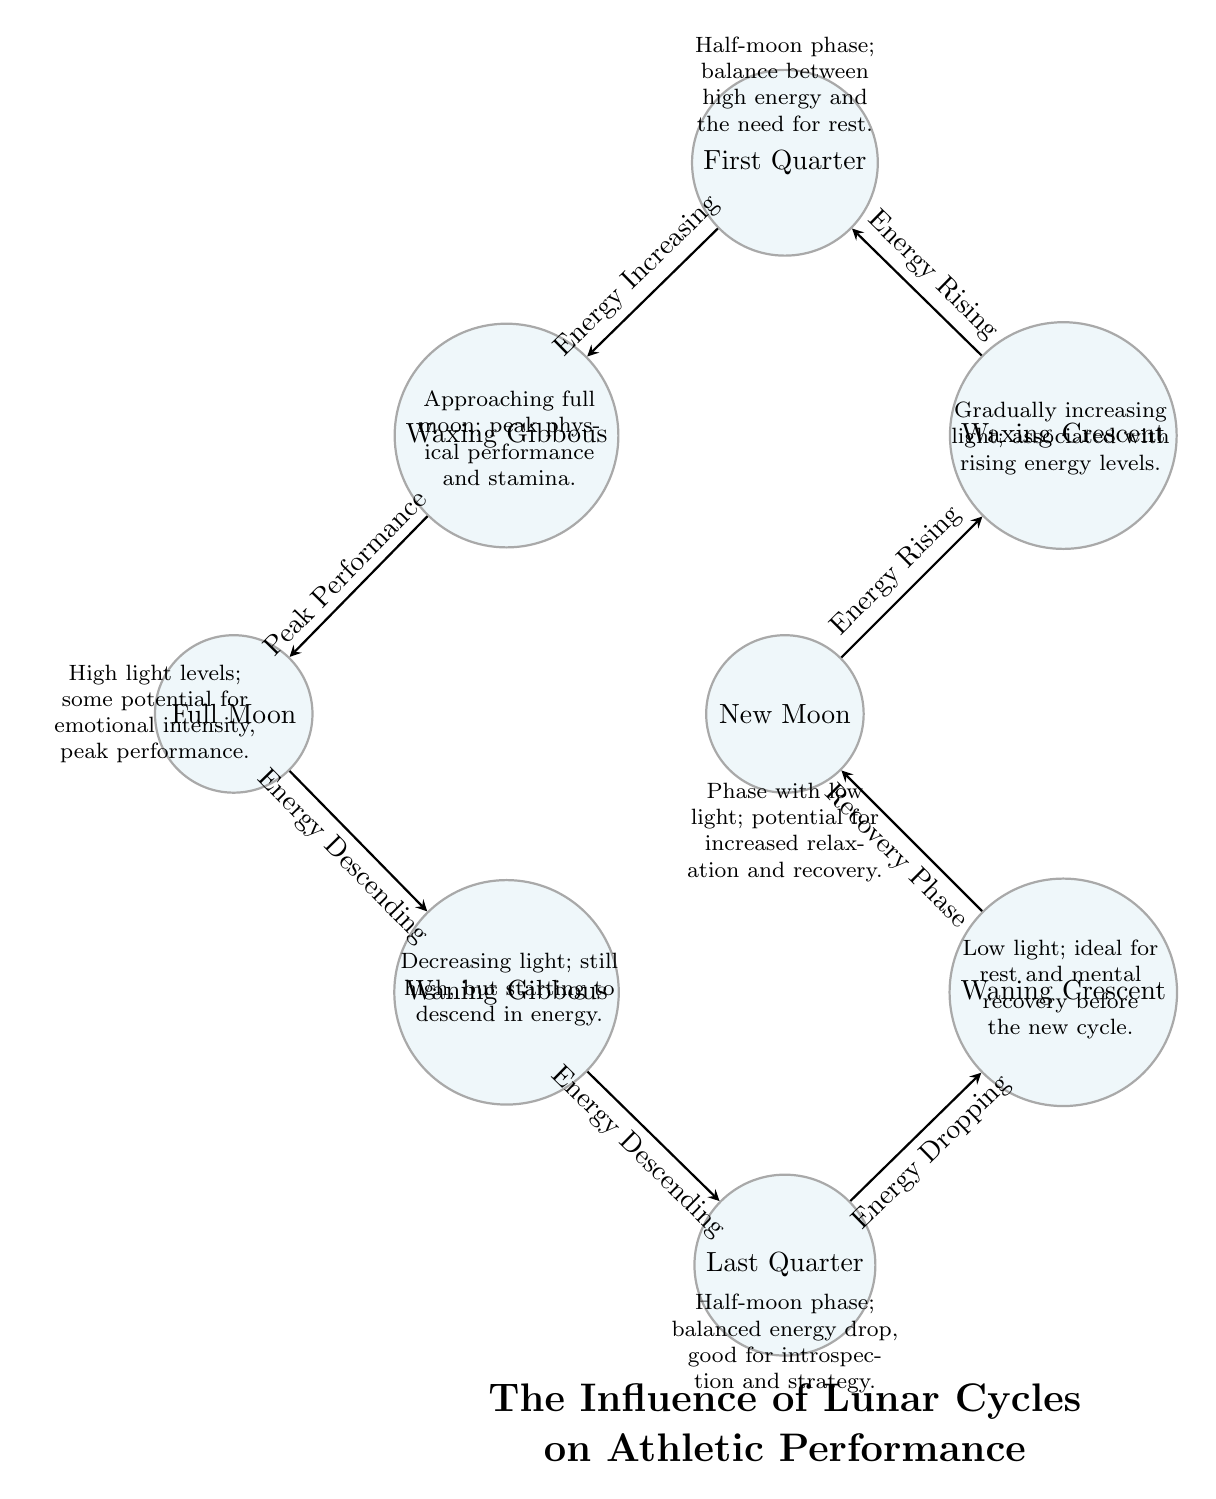What is the first moon phase mentioned in the diagram? The first node in the diagram is labeled "New Moon," indicating that this is the first phase presented.
Answer: New Moon How many moon phases are represented in the diagram? The diagram shows a total of eight nodes, each representing a different moon phase. Thus, there are eight moon phases.
Answer: 8 Which phase has energy increasing? The arrows indicate that energy is increasing from the "Waxing Crescent" to the "First Quarter" and from the "First Quarter" to the "Waxing Gibbous." The query asks for a specific phase where this occurs; "First Quarter" meets this criterion as it follows a phase with rising energy.
Answer: First Quarter What is the relationship between the Full Moon and the Waning Gibbous? The diagram states that after reaching "Full Moon," the energy is descending toward the "Waning Gibbous." This indicates that following the peak performance at the Full Moon, there is a decrease in energy.
Answer: Energy Descending Which moon phase is associated with peak performance? The diagram clearly labels the "Full Moon" as the phase where peak physical performance and stamina are observed, making it the focus for athletes aiming for high performance.
Answer: Full Moon In which phase is energy dropping described? The diagram indicates that during the "Waning Crescent," the energy is described as dropping. This information is collected from the edges indicating that energy culminates in a drop from the previous phases.
Answer: Waning Crescent What type of phase is the New Moon classified as? The New Moon is described as having low light and being a potential recovery phase, which frames its classification as a phase suited for relaxation and restoration in athletic training contexts.
Answer: Recovery Phase What follows after the Waxing Gibbous phase according to the diagram? The transition from the "Waxing Gibbous" phase leads directly to the "Full Moon" phase, marking the peak energy and performance potential in the lunar cycle.
Answer: Full Moon Which phase is associated with recovery and introspection? The diagram attributes the "Waning Crescent" phase as ideal for rest and mental recovery, emphasizing its role in the lunar cycle as a time for reflection before the next cycle begins.
Answer: Waning Crescent 